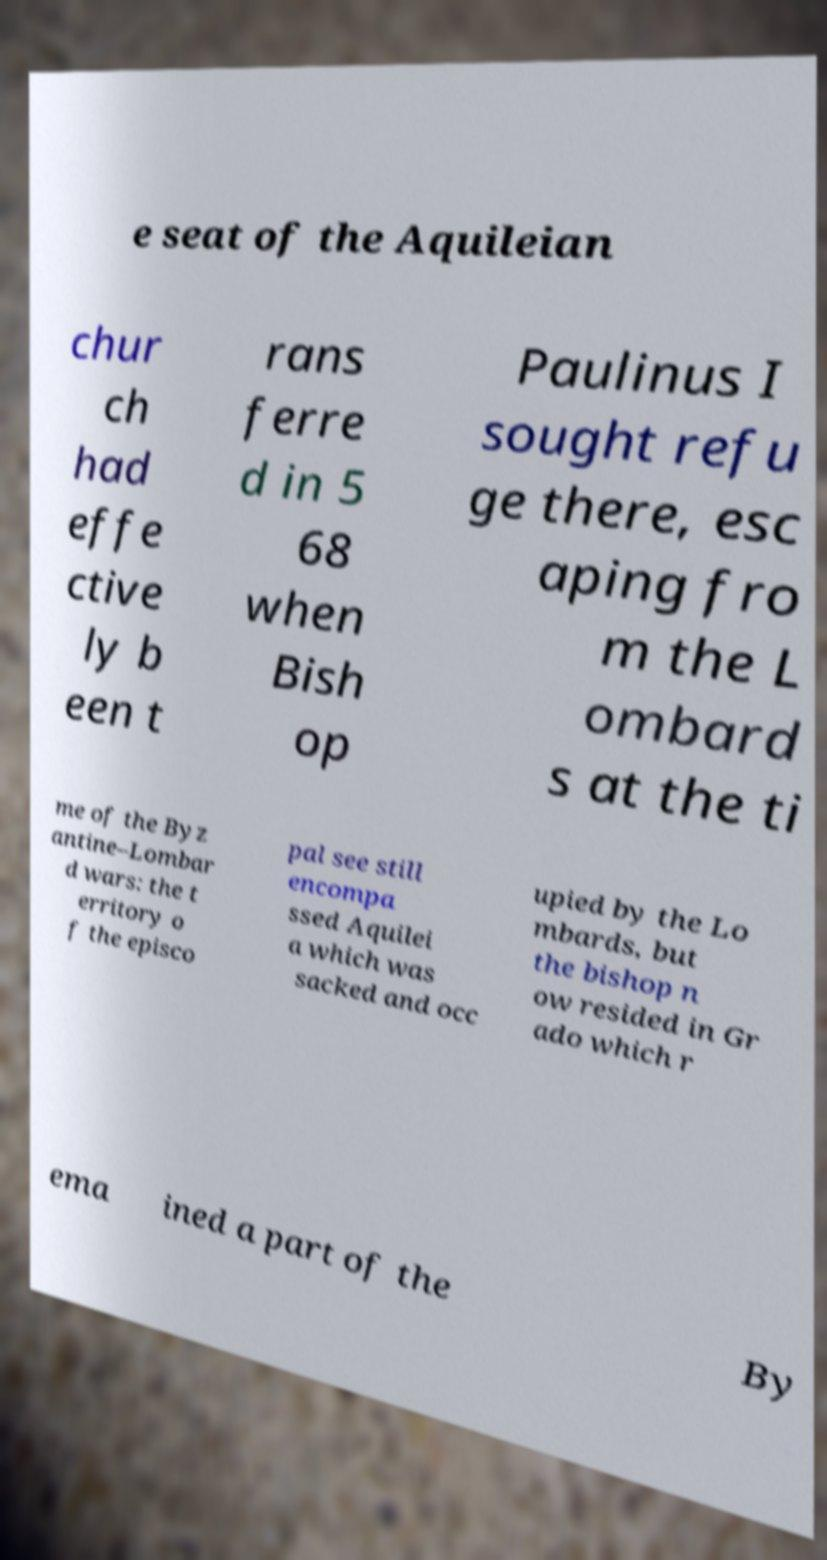Could you assist in decoding the text presented in this image and type it out clearly? e seat of the Aquileian chur ch had effe ctive ly b een t rans ferre d in 5 68 when Bish op Paulinus I sought refu ge there, esc aping fro m the L ombard s at the ti me of the Byz antine–Lombar d wars: the t erritory o f the episco pal see still encompa ssed Aquilei a which was sacked and occ upied by the Lo mbards, but the bishop n ow resided in Gr ado which r ema ined a part of the By 